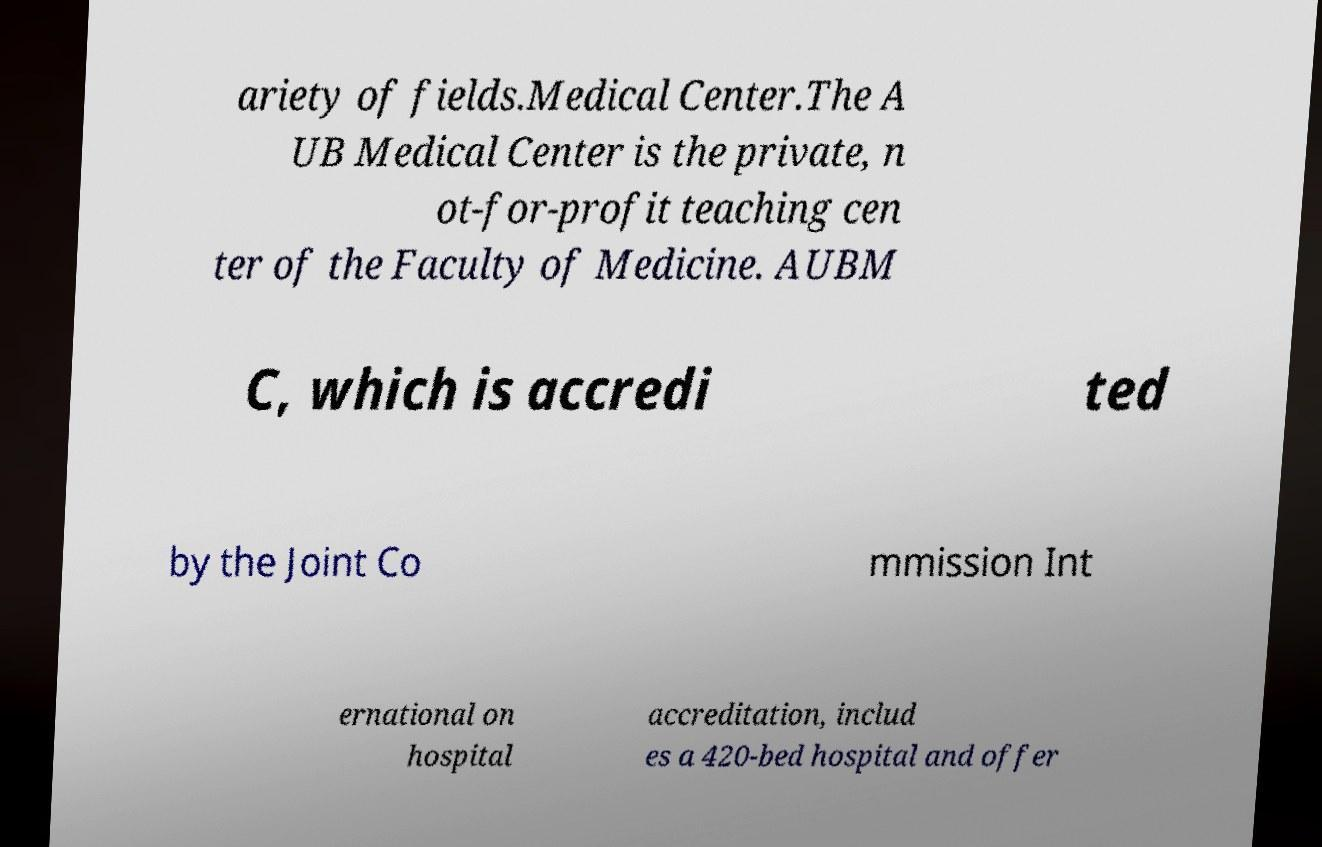Could you extract and type out the text from this image? ariety of fields.Medical Center.The A UB Medical Center is the private, n ot-for-profit teaching cen ter of the Faculty of Medicine. AUBM C, which is accredi ted by the Joint Co mmission Int ernational on hospital accreditation, includ es a 420-bed hospital and offer 